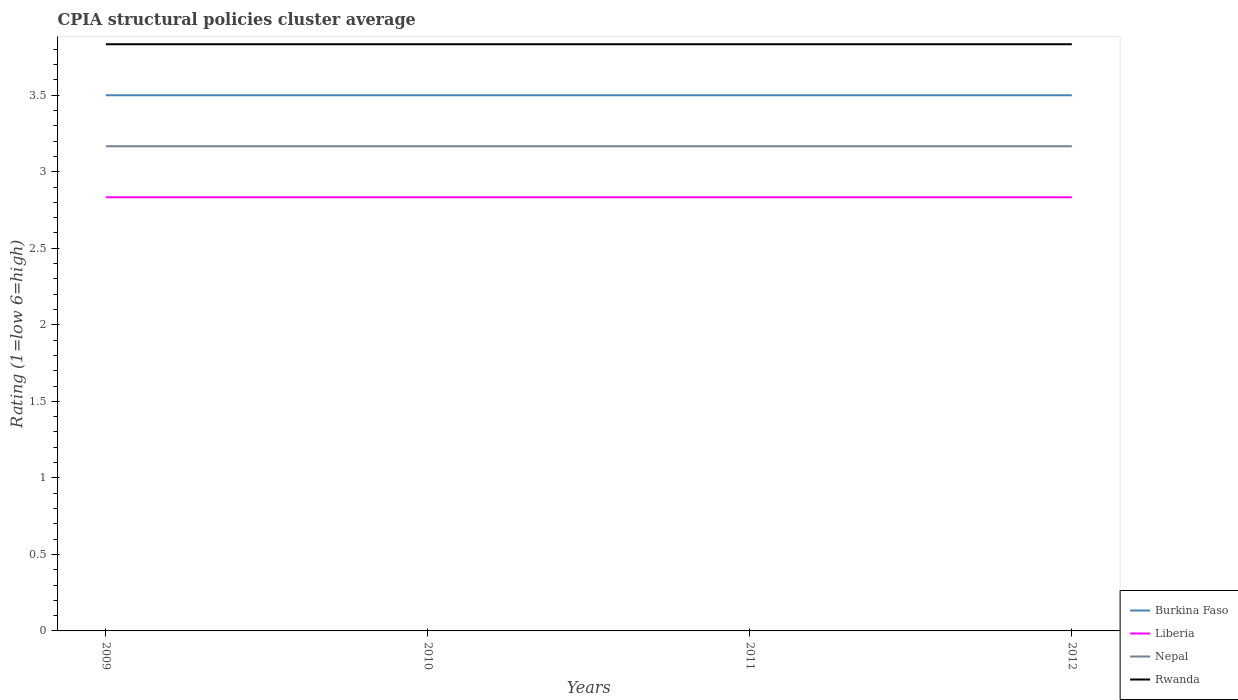How many different coloured lines are there?
Give a very brief answer. 4. Does the line corresponding to Liberia intersect with the line corresponding to Rwanda?
Make the answer very short. No. Across all years, what is the maximum CPIA rating in Nepal?
Make the answer very short. 3.17. What is the total CPIA rating in Liberia in the graph?
Your answer should be compact. 0. How many lines are there?
Ensure brevity in your answer.  4. Does the graph contain any zero values?
Your response must be concise. No. Does the graph contain grids?
Give a very brief answer. No. Where does the legend appear in the graph?
Ensure brevity in your answer.  Bottom right. What is the title of the graph?
Your answer should be very brief. CPIA structural policies cluster average. Does "World" appear as one of the legend labels in the graph?
Provide a short and direct response. No. What is the label or title of the X-axis?
Provide a short and direct response. Years. What is the label or title of the Y-axis?
Your answer should be compact. Rating (1=low 6=high). What is the Rating (1=low 6=high) in Liberia in 2009?
Offer a very short reply. 2.83. What is the Rating (1=low 6=high) in Nepal in 2009?
Your response must be concise. 3.17. What is the Rating (1=low 6=high) in Rwanda in 2009?
Your response must be concise. 3.83. What is the Rating (1=low 6=high) of Burkina Faso in 2010?
Keep it short and to the point. 3.5. What is the Rating (1=low 6=high) in Liberia in 2010?
Your answer should be compact. 2.83. What is the Rating (1=low 6=high) of Nepal in 2010?
Your response must be concise. 3.17. What is the Rating (1=low 6=high) in Rwanda in 2010?
Your response must be concise. 3.83. What is the Rating (1=low 6=high) in Liberia in 2011?
Ensure brevity in your answer.  2.83. What is the Rating (1=low 6=high) of Nepal in 2011?
Your answer should be very brief. 3.17. What is the Rating (1=low 6=high) of Rwanda in 2011?
Your answer should be compact. 3.83. What is the Rating (1=low 6=high) of Burkina Faso in 2012?
Provide a succinct answer. 3.5. What is the Rating (1=low 6=high) in Liberia in 2012?
Make the answer very short. 2.83. What is the Rating (1=low 6=high) of Nepal in 2012?
Your answer should be very brief. 3.17. What is the Rating (1=low 6=high) in Rwanda in 2012?
Your response must be concise. 3.83. Across all years, what is the maximum Rating (1=low 6=high) in Liberia?
Offer a terse response. 2.83. Across all years, what is the maximum Rating (1=low 6=high) of Nepal?
Your answer should be compact. 3.17. Across all years, what is the maximum Rating (1=low 6=high) of Rwanda?
Provide a short and direct response. 3.83. Across all years, what is the minimum Rating (1=low 6=high) of Burkina Faso?
Your response must be concise. 3.5. Across all years, what is the minimum Rating (1=low 6=high) in Liberia?
Your answer should be very brief. 2.83. Across all years, what is the minimum Rating (1=low 6=high) in Nepal?
Offer a very short reply. 3.17. Across all years, what is the minimum Rating (1=low 6=high) of Rwanda?
Offer a very short reply. 3.83. What is the total Rating (1=low 6=high) in Liberia in the graph?
Provide a short and direct response. 11.33. What is the total Rating (1=low 6=high) of Nepal in the graph?
Offer a very short reply. 12.67. What is the total Rating (1=low 6=high) in Rwanda in the graph?
Make the answer very short. 15.33. What is the difference between the Rating (1=low 6=high) of Burkina Faso in 2009 and that in 2010?
Ensure brevity in your answer.  0. What is the difference between the Rating (1=low 6=high) in Nepal in 2009 and that in 2010?
Provide a succinct answer. 0. What is the difference between the Rating (1=low 6=high) of Rwanda in 2009 and that in 2010?
Give a very brief answer. 0. What is the difference between the Rating (1=low 6=high) of Burkina Faso in 2009 and that in 2011?
Offer a very short reply. 0. What is the difference between the Rating (1=low 6=high) of Liberia in 2009 and that in 2011?
Ensure brevity in your answer.  0. What is the difference between the Rating (1=low 6=high) in Burkina Faso in 2009 and that in 2012?
Offer a very short reply. 0. What is the difference between the Rating (1=low 6=high) of Liberia in 2009 and that in 2012?
Ensure brevity in your answer.  0. What is the difference between the Rating (1=low 6=high) of Nepal in 2009 and that in 2012?
Your answer should be very brief. 0. What is the difference between the Rating (1=low 6=high) of Liberia in 2010 and that in 2011?
Provide a succinct answer. 0. What is the difference between the Rating (1=low 6=high) in Rwanda in 2010 and that in 2011?
Give a very brief answer. 0. What is the difference between the Rating (1=low 6=high) in Burkina Faso in 2010 and that in 2012?
Your response must be concise. 0. What is the difference between the Rating (1=low 6=high) of Rwanda in 2010 and that in 2012?
Provide a succinct answer. 0. What is the difference between the Rating (1=low 6=high) in Burkina Faso in 2011 and that in 2012?
Ensure brevity in your answer.  0. What is the difference between the Rating (1=low 6=high) of Nepal in 2011 and that in 2012?
Offer a very short reply. 0. What is the difference between the Rating (1=low 6=high) of Burkina Faso in 2009 and the Rating (1=low 6=high) of Liberia in 2010?
Your answer should be compact. 0.67. What is the difference between the Rating (1=low 6=high) of Burkina Faso in 2009 and the Rating (1=low 6=high) of Nepal in 2010?
Keep it short and to the point. 0.33. What is the difference between the Rating (1=low 6=high) of Liberia in 2009 and the Rating (1=low 6=high) of Nepal in 2010?
Your answer should be compact. -0.33. What is the difference between the Rating (1=low 6=high) in Liberia in 2009 and the Rating (1=low 6=high) in Rwanda in 2010?
Provide a succinct answer. -1. What is the difference between the Rating (1=low 6=high) of Burkina Faso in 2009 and the Rating (1=low 6=high) of Liberia in 2011?
Give a very brief answer. 0.67. What is the difference between the Rating (1=low 6=high) in Liberia in 2009 and the Rating (1=low 6=high) in Rwanda in 2011?
Offer a terse response. -1. What is the difference between the Rating (1=low 6=high) in Burkina Faso in 2009 and the Rating (1=low 6=high) in Liberia in 2012?
Your answer should be compact. 0.67. What is the difference between the Rating (1=low 6=high) of Burkina Faso in 2009 and the Rating (1=low 6=high) of Rwanda in 2012?
Give a very brief answer. -0.33. What is the difference between the Rating (1=low 6=high) of Liberia in 2009 and the Rating (1=low 6=high) of Nepal in 2012?
Your answer should be compact. -0.33. What is the difference between the Rating (1=low 6=high) in Liberia in 2009 and the Rating (1=low 6=high) in Rwanda in 2012?
Give a very brief answer. -1. What is the difference between the Rating (1=low 6=high) in Nepal in 2009 and the Rating (1=low 6=high) in Rwanda in 2012?
Offer a very short reply. -0.67. What is the difference between the Rating (1=low 6=high) of Burkina Faso in 2010 and the Rating (1=low 6=high) of Liberia in 2011?
Offer a very short reply. 0.67. What is the difference between the Rating (1=low 6=high) of Burkina Faso in 2010 and the Rating (1=low 6=high) of Rwanda in 2011?
Make the answer very short. -0.33. What is the difference between the Rating (1=low 6=high) of Liberia in 2010 and the Rating (1=low 6=high) of Rwanda in 2011?
Keep it short and to the point. -1. What is the difference between the Rating (1=low 6=high) of Burkina Faso in 2010 and the Rating (1=low 6=high) of Rwanda in 2012?
Keep it short and to the point. -0.33. What is the difference between the Rating (1=low 6=high) of Burkina Faso in 2011 and the Rating (1=low 6=high) of Liberia in 2012?
Your answer should be very brief. 0.67. What is the difference between the Rating (1=low 6=high) in Burkina Faso in 2011 and the Rating (1=low 6=high) in Rwanda in 2012?
Give a very brief answer. -0.33. What is the difference between the Rating (1=low 6=high) in Liberia in 2011 and the Rating (1=low 6=high) in Rwanda in 2012?
Offer a terse response. -1. What is the difference between the Rating (1=low 6=high) of Nepal in 2011 and the Rating (1=low 6=high) of Rwanda in 2012?
Offer a very short reply. -0.67. What is the average Rating (1=low 6=high) in Liberia per year?
Give a very brief answer. 2.83. What is the average Rating (1=low 6=high) of Nepal per year?
Provide a succinct answer. 3.17. What is the average Rating (1=low 6=high) of Rwanda per year?
Give a very brief answer. 3.83. In the year 2009, what is the difference between the Rating (1=low 6=high) of Burkina Faso and Rating (1=low 6=high) of Liberia?
Your answer should be very brief. 0.67. In the year 2009, what is the difference between the Rating (1=low 6=high) in Burkina Faso and Rating (1=low 6=high) in Nepal?
Keep it short and to the point. 0.33. In the year 2009, what is the difference between the Rating (1=low 6=high) in Burkina Faso and Rating (1=low 6=high) in Rwanda?
Offer a very short reply. -0.33. In the year 2009, what is the difference between the Rating (1=low 6=high) of Liberia and Rating (1=low 6=high) of Nepal?
Make the answer very short. -0.33. In the year 2009, what is the difference between the Rating (1=low 6=high) in Liberia and Rating (1=low 6=high) in Rwanda?
Offer a terse response. -1. In the year 2009, what is the difference between the Rating (1=low 6=high) of Nepal and Rating (1=low 6=high) of Rwanda?
Your answer should be compact. -0.67. In the year 2010, what is the difference between the Rating (1=low 6=high) of Burkina Faso and Rating (1=low 6=high) of Liberia?
Your answer should be very brief. 0.67. In the year 2010, what is the difference between the Rating (1=low 6=high) in Liberia and Rating (1=low 6=high) in Nepal?
Keep it short and to the point. -0.33. In the year 2010, what is the difference between the Rating (1=low 6=high) in Liberia and Rating (1=low 6=high) in Rwanda?
Your answer should be very brief. -1. In the year 2011, what is the difference between the Rating (1=low 6=high) in Burkina Faso and Rating (1=low 6=high) in Nepal?
Keep it short and to the point. 0.33. In the year 2011, what is the difference between the Rating (1=low 6=high) of Liberia and Rating (1=low 6=high) of Rwanda?
Make the answer very short. -1. In the year 2011, what is the difference between the Rating (1=low 6=high) of Nepal and Rating (1=low 6=high) of Rwanda?
Give a very brief answer. -0.67. In the year 2012, what is the difference between the Rating (1=low 6=high) in Burkina Faso and Rating (1=low 6=high) in Liberia?
Give a very brief answer. 0.67. In the year 2012, what is the difference between the Rating (1=low 6=high) in Liberia and Rating (1=low 6=high) in Rwanda?
Your answer should be compact. -1. What is the ratio of the Rating (1=low 6=high) of Burkina Faso in 2009 to that in 2010?
Your response must be concise. 1. What is the ratio of the Rating (1=low 6=high) of Rwanda in 2009 to that in 2010?
Provide a short and direct response. 1. What is the ratio of the Rating (1=low 6=high) in Burkina Faso in 2009 to that in 2011?
Make the answer very short. 1. What is the ratio of the Rating (1=low 6=high) in Liberia in 2009 to that in 2011?
Make the answer very short. 1. What is the ratio of the Rating (1=low 6=high) in Rwanda in 2009 to that in 2011?
Offer a very short reply. 1. What is the ratio of the Rating (1=low 6=high) of Liberia in 2009 to that in 2012?
Offer a very short reply. 1. What is the ratio of the Rating (1=low 6=high) in Burkina Faso in 2010 to that in 2011?
Offer a very short reply. 1. What is the ratio of the Rating (1=low 6=high) of Nepal in 2010 to that in 2011?
Offer a very short reply. 1. What is the ratio of the Rating (1=low 6=high) in Burkina Faso in 2010 to that in 2012?
Make the answer very short. 1. What is the ratio of the Rating (1=low 6=high) of Liberia in 2010 to that in 2012?
Ensure brevity in your answer.  1. What is the ratio of the Rating (1=low 6=high) of Burkina Faso in 2011 to that in 2012?
Ensure brevity in your answer.  1. What is the ratio of the Rating (1=low 6=high) in Liberia in 2011 to that in 2012?
Ensure brevity in your answer.  1. What is the ratio of the Rating (1=low 6=high) of Nepal in 2011 to that in 2012?
Offer a very short reply. 1. What is the ratio of the Rating (1=low 6=high) in Rwanda in 2011 to that in 2012?
Give a very brief answer. 1. What is the difference between the highest and the second highest Rating (1=low 6=high) in Liberia?
Your answer should be compact. 0. What is the difference between the highest and the lowest Rating (1=low 6=high) of Liberia?
Provide a short and direct response. 0. What is the difference between the highest and the lowest Rating (1=low 6=high) of Nepal?
Ensure brevity in your answer.  0. What is the difference between the highest and the lowest Rating (1=low 6=high) in Rwanda?
Make the answer very short. 0. 